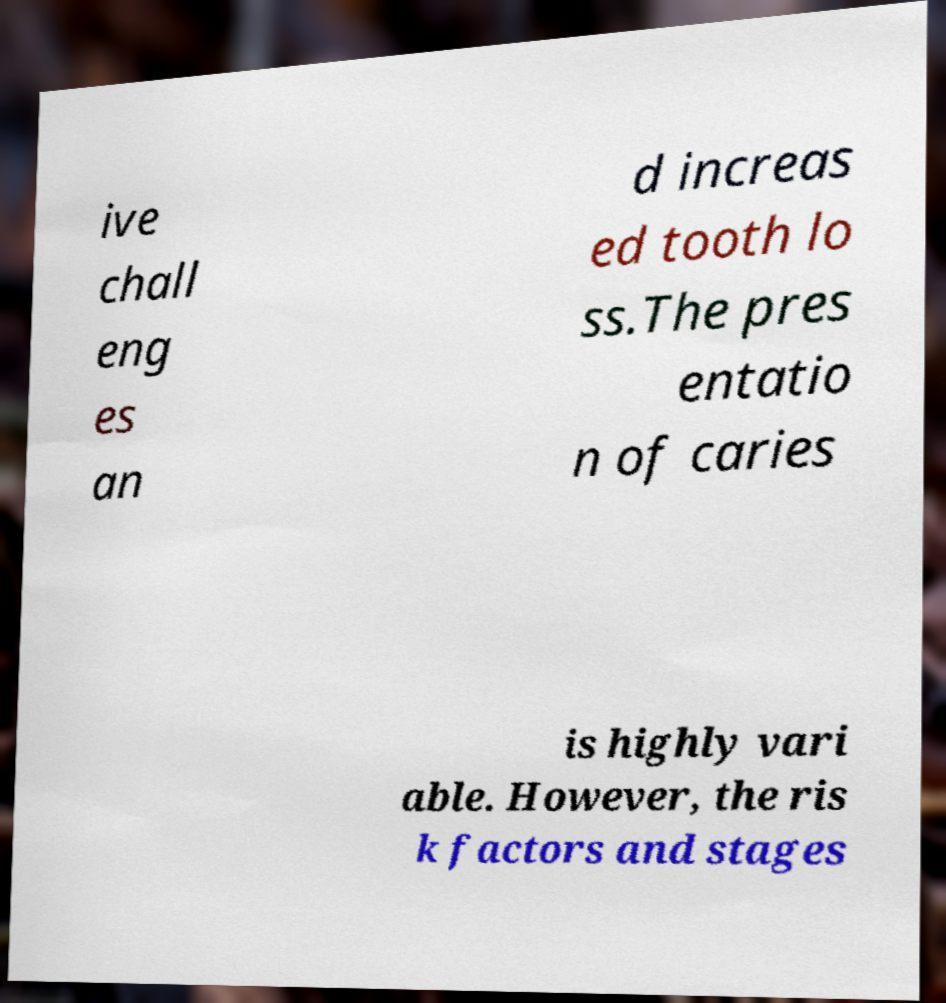What messages or text are displayed in this image? I need them in a readable, typed format. ive chall eng es an d increas ed tooth lo ss.The pres entatio n of caries is highly vari able. However, the ris k factors and stages 